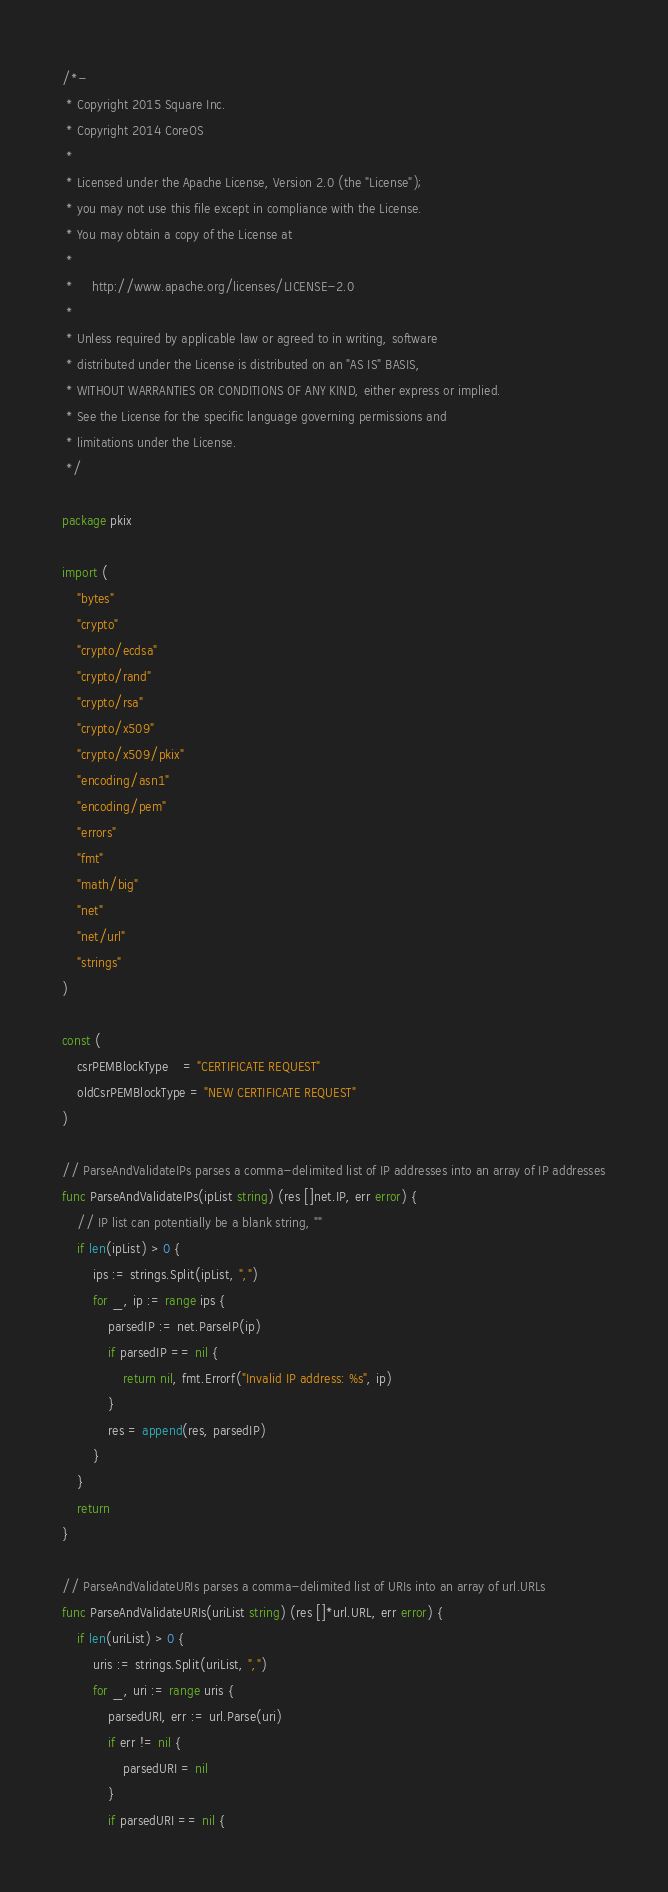<code> <loc_0><loc_0><loc_500><loc_500><_Go_>/*-
 * Copyright 2015 Square Inc.
 * Copyright 2014 CoreOS
 *
 * Licensed under the Apache License, Version 2.0 (the "License");
 * you may not use this file except in compliance with the License.
 * You may obtain a copy of the License at
 *
 *     http://www.apache.org/licenses/LICENSE-2.0
 *
 * Unless required by applicable law or agreed to in writing, software
 * distributed under the License is distributed on an "AS IS" BASIS,
 * WITHOUT WARRANTIES OR CONDITIONS OF ANY KIND, either express or implied.
 * See the License for the specific language governing permissions and
 * limitations under the License.
 */

package pkix

import (
	"bytes"
	"crypto"
	"crypto/ecdsa"
	"crypto/rand"
	"crypto/rsa"
	"crypto/x509"
	"crypto/x509/pkix"
	"encoding/asn1"
	"encoding/pem"
	"errors"
	"fmt"
	"math/big"
	"net"
	"net/url"
	"strings"
)

const (
	csrPEMBlockType    = "CERTIFICATE REQUEST"
	oldCsrPEMBlockType = "NEW CERTIFICATE REQUEST"
)

// ParseAndValidateIPs parses a comma-delimited list of IP addresses into an array of IP addresses
func ParseAndValidateIPs(ipList string) (res []net.IP, err error) {
	// IP list can potentially be a blank string, ""
	if len(ipList) > 0 {
		ips := strings.Split(ipList, ",")
		for _, ip := range ips {
			parsedIP := net.ParseIP(ip)
			if parsedIP == nil {
				return nil, fmt.Errorf("Invalid IP address: %s", ip)
			}
			res = append(res, parsedIP)
		}
	}
	return
}

// ParseAndValidateURIs parses a comma-delimited list of URIs into an array of url.URLs
func ParseAndValidateURIs(uriList string) (res []*url.URL, err error) {
	if len(uriList) > 0 {
		uris := strings.Split(uriList, ",")
		for _, uri := range uris {
			parsedURI, err := url.Parse(uri)
			if err != nil {
				parsedURI = nil
			}
			if parsedURI == nil {</code> 